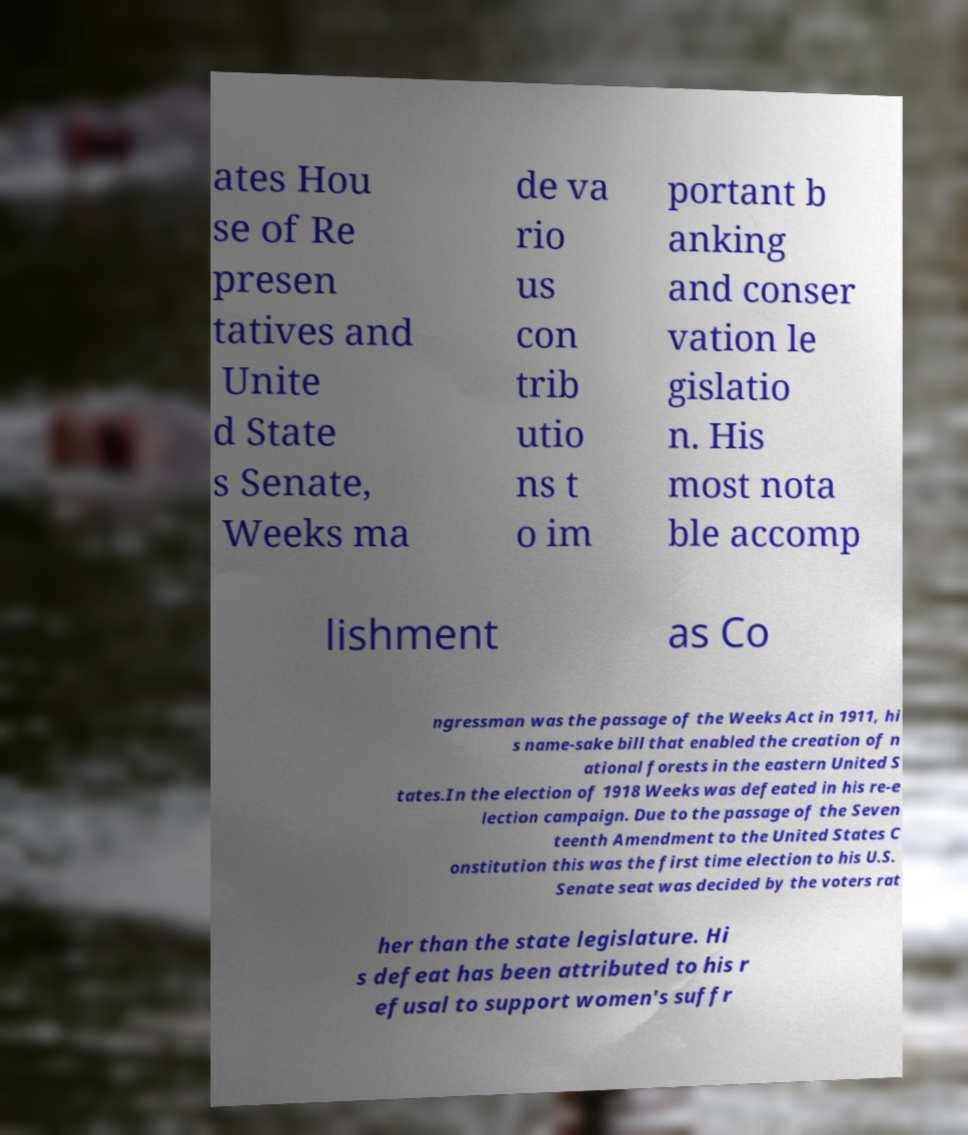Can you read and provide the text displayed in the image?This photo seems to have some interesting text. Can you extract and type it out for me? ates Hou se of Re presen tatives and Unite d State s Senate, Weeks ma de va rio us con trib utio ns t o im portant b anking and conser vation le gislatio n. His most nota ble accomp lishment as Co ngressman was the passage of the Weeks Act in 1911, hi s name-sake bill that enabled the creation of n ational forests in the eastern United S tates.In the election of 1918 Weeks was defeated in his re-e lection campaign. Due to the passage of the Seven teenth Amendment to the United States C onstitution this was the first time election to his U.S. Senate seat was decided by the voters rat her than the state legislature. Hi s defeat has been attributed to his r efusal to support women's suffr 